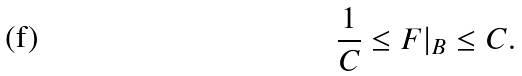Convert formula to latex. <formula><loc_0><loc_0><loc_500><loc_500>\frac { 1 } { C } \leq F | _ { B } \leq C .</formula> 